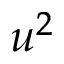Convert formula to latex. <formula><loc_0><loc_0><loc_500><loc_500>u ^ { 2 }</formula> 